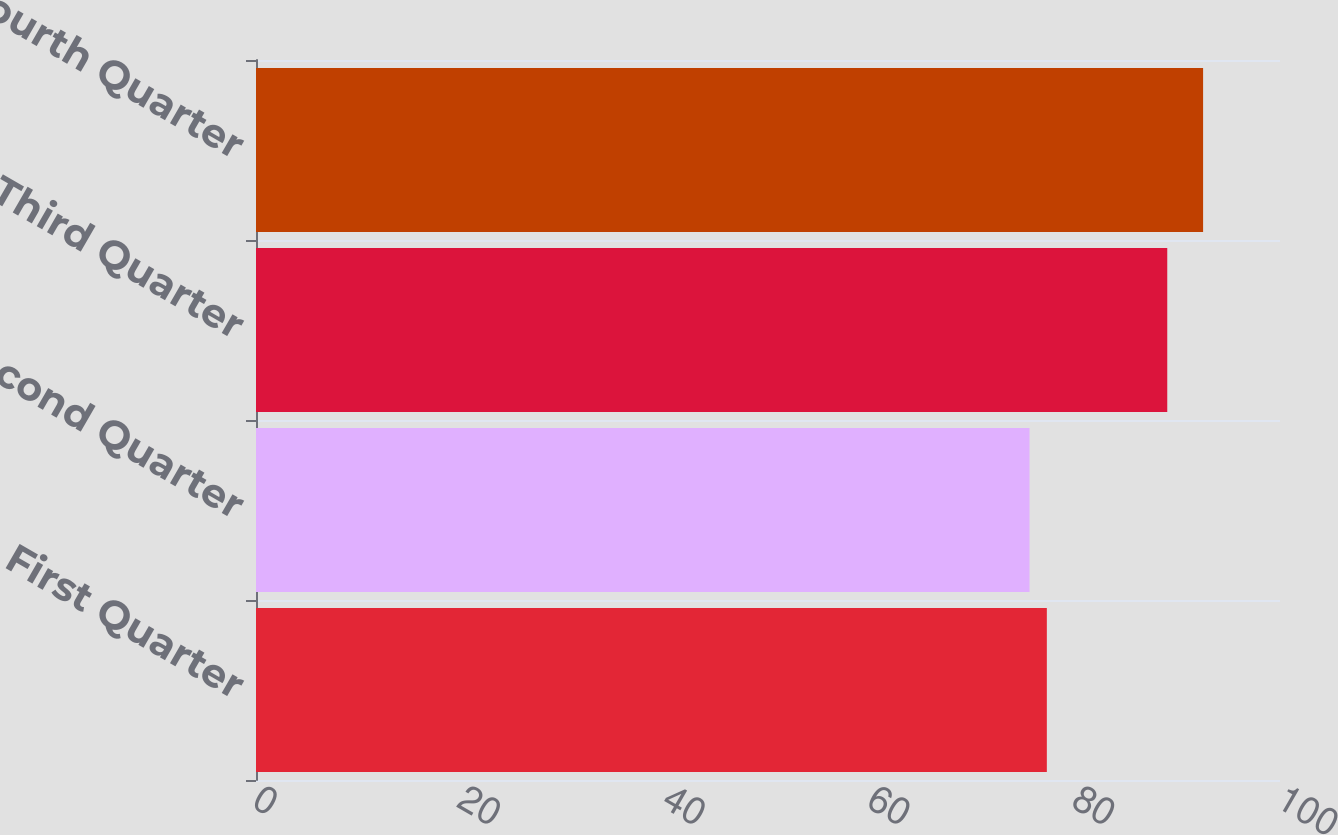Convert chart. <chart><loc_0><loc_0><loc_500><loc_500><bar_chart><fcel>First Quarter<fcel>Second Quarter<fcel>Third Quarter<fcel>Fourth Quarter<nl><fcel>77.23<fcel>75.54<fcel>88.99<fcel>92.49<nl></chart> 